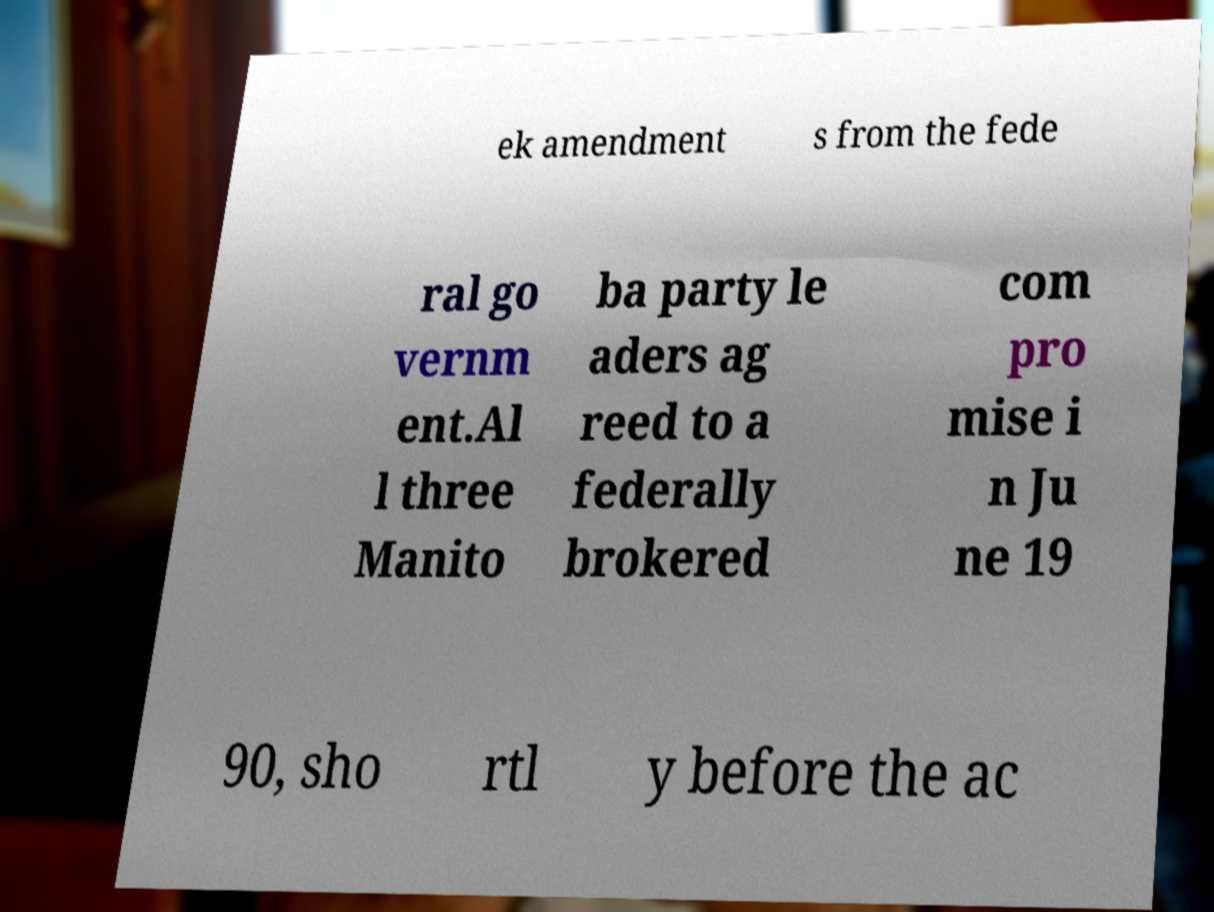Could you assist in decoding the text presented in this image and type it out clearly? ek amendment s from the fede ral go vernm ent.Al l three Manito ba party le aders ag reed to a federally brokered com pro mise i n Ju ne 19 90, sho rtl y before the ac 